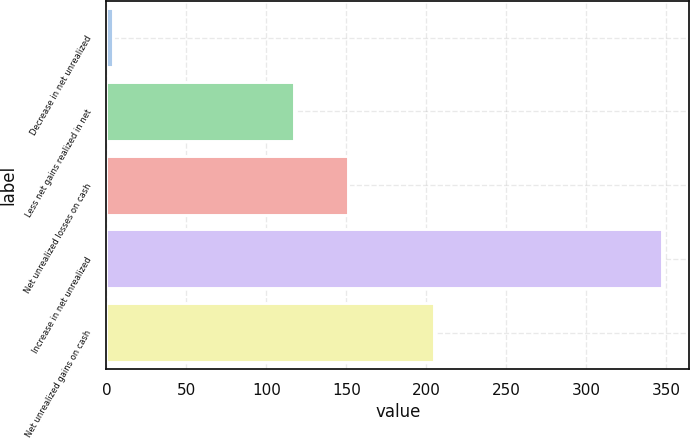Convert chart. <chart><loc_0><loc_0><loc_500><loc_500><bar_chart><fcel>Decrease in net unrealized<fcel>Less net gains realized in net<fcel>Net unrealized losses on cash<fcel>Increase in net unrealized<fcel>Net unrealized gains on cash<nl><fcel>4<fcel>117<fcel>151.3<fcel>347<fcel>205<nl></chart> 